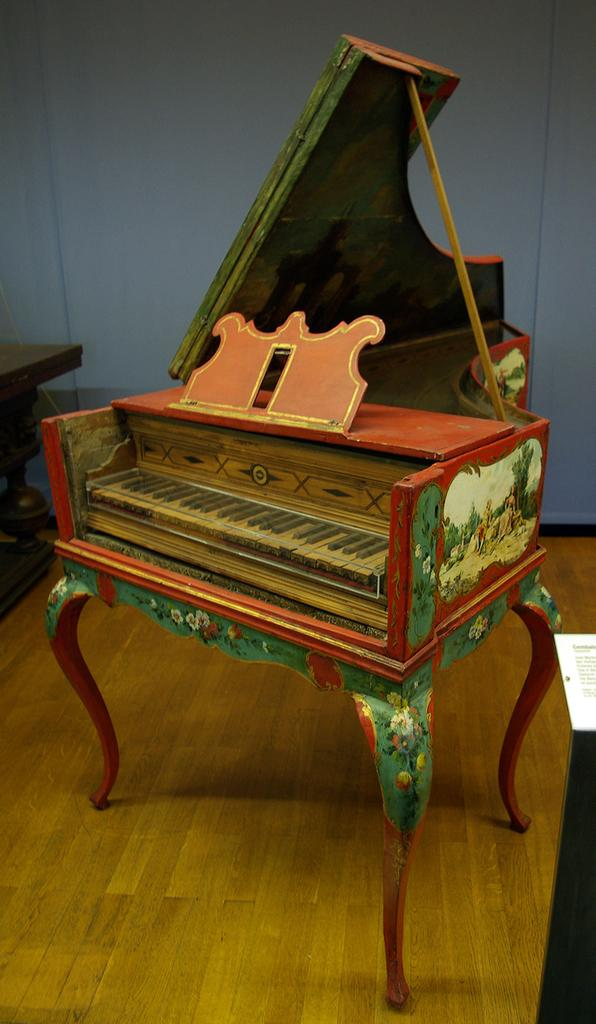What musical instrument is present in the image? There is a piano in the image. How many deer can be seen playing the piano in the image? There are no deer present in the image, and the piano is not being played by any animals. 